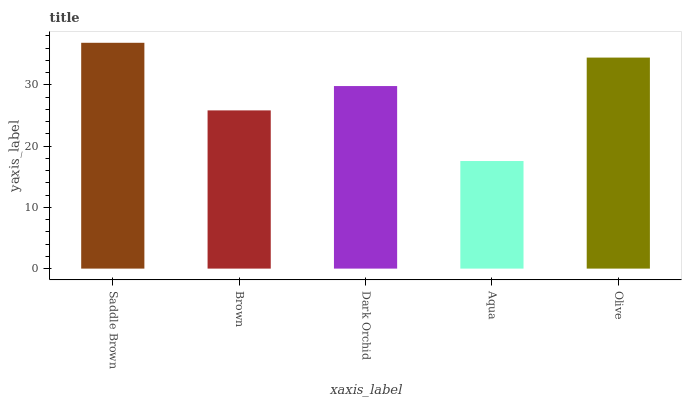Is Brown the minimum?
Answer yes or no. No. Is Brown the maximum?
Answer yes or no. No. Is Saddle Brown greater than Brown?
Answer yes or no. Yes. Is Brown less than Saddle Brown?
Answer yes or no. Yes. Is Brown greater than Saddle Brown?
Answer yes or no. No. Is Saddle Brown less than Brown?
Answer yes or no. No. Is Dark Orchid the high median?
Answer yes or no. Yes. Is Dark Orchid the low median?
Answer yes or no. Yes. Is Brown the high median?
Answer yes or no. No. Is Aqua the low median?
Answer yes or no. No. 